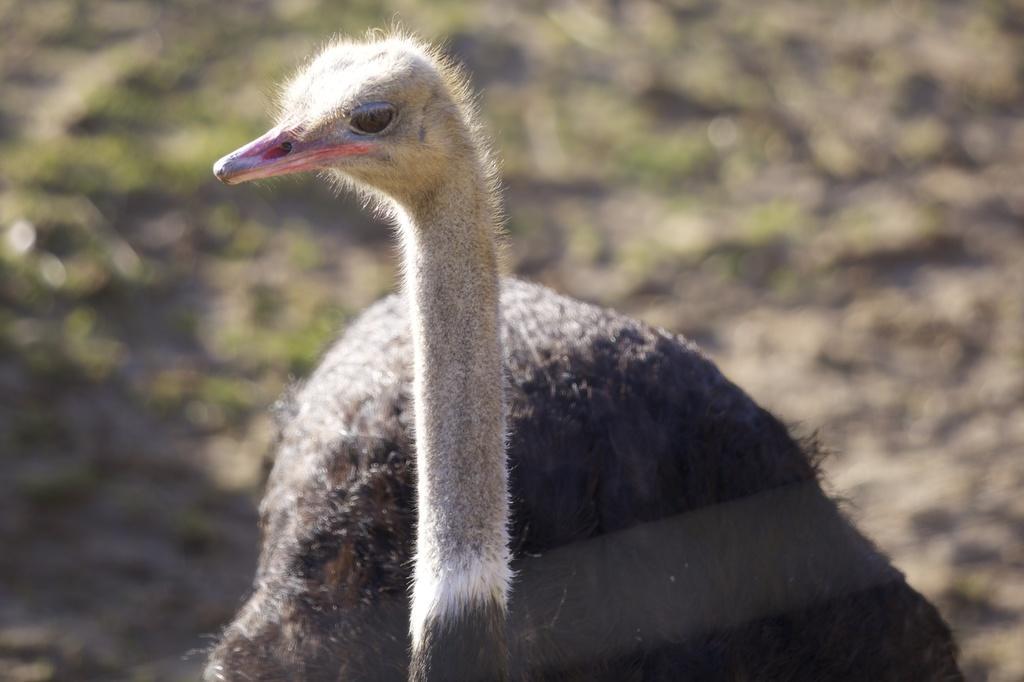Describe this image in one or two sentences. In the image we can see the ostrich, grass and the background is blurred. 